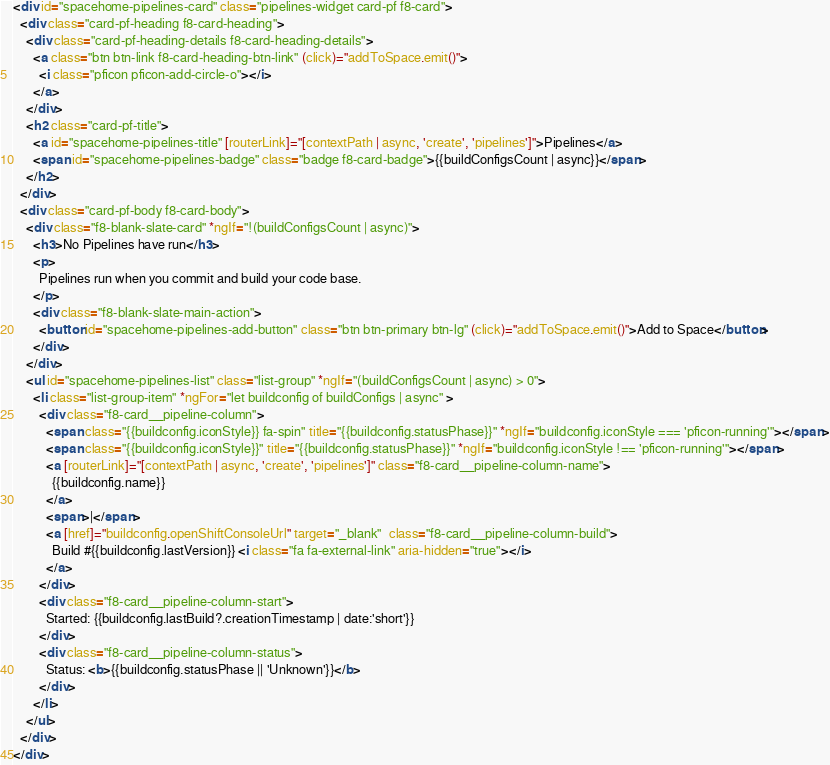<code> <loc_0><loc_0><loc_500><loc_500><_HTML_><div id="spacehome-pipelines-card" class="pipelines-widget card-pf f8-card">
  <div class="card-pf-heading f8-card-heading">
    <div class="card-pf-heading-details f8-card-heading-details">
      <a class="btn btn-link f8-card-heading-btn-link" (click)="addToSpace.emit()">
        <i class="pficon pficon-add-circle-o"></i>
      </a>
    </div>
    <h2 class="card-pf-title">
      <a id="spacehome-pipelines-title" [routerLink]="[contextPath | async, 'create', 'pipelines']">Pipelines</a>
      <span id="spacehome-pipelines-badge" class="badge f8-card-badge">{{buildConfigsCount | async}}</span>
    </h2>
  </div>
  <div class="card-pf-body f8-card-body">
    <div class="f8-blank-slate-card" *ngIf="!(buildConfigsCount | async)">
      <h3>No Pipelines have run</h3>
      <p>
        Pipelines run when you commit and build your code base.
      </p>
      <div class="f8-blank-slate-main-action">
        <button id="spacehome-pipelines-add-button" class="btn btn-primary btn-lg" (click)="addToSpace.emit()">Add to Space</button>
      </div>
    </div>
    <ul id="spacehome-pipelines-list" class="list-group" *ngIf="(buildConfigsCount | async) > 0">
      <li class="list-group-item" *ngFor="let buildconfig of buildConfigs | async" >
        <div class="f8-card__pipeline-column">
          <span class="{{buildconfig.iconStyle}} fa-spin" title="{{buildconfig.statusPhase}}" *ngIf="buildconfig.iconStyle === 'pficon-running'"></span>
          <span class="{{buildconfig.iconStyle}}" title="{{buildconfig.statusPhase}}" *ngIf="buildconfig.iconStyle !== 'pficon-running'"></span>
          <a [routerLink]="[contextPath | async, 'create', 'pipelines']" class="f8-card__pipeline-column-name">
            {{buildconfig.name}}
          </a>
          <span>|</span>
          <a [href]="buildconfig.openShiftConsoleUrl" target="_blank"  class="f8-card__pipeline-column-build">
            Build #{{buildconfig.lastVersion}} <i class="fa fa-external-link" aria-hidden="true"></i>
          </a>
        </div>
        <div class="f8-card__pipeline-column-start">
          Started: {{buildconfig.lastBuild?.creationTimestamp | date:'short'}}
        </div>
        <div class="f8-card__pipeline-column-status">
          Status: <b>{{buildconfig.statusPhase || 'Unknown'}}</b>
        </div>
      </li>
    </ul>
  </div>
</div>
</code> 